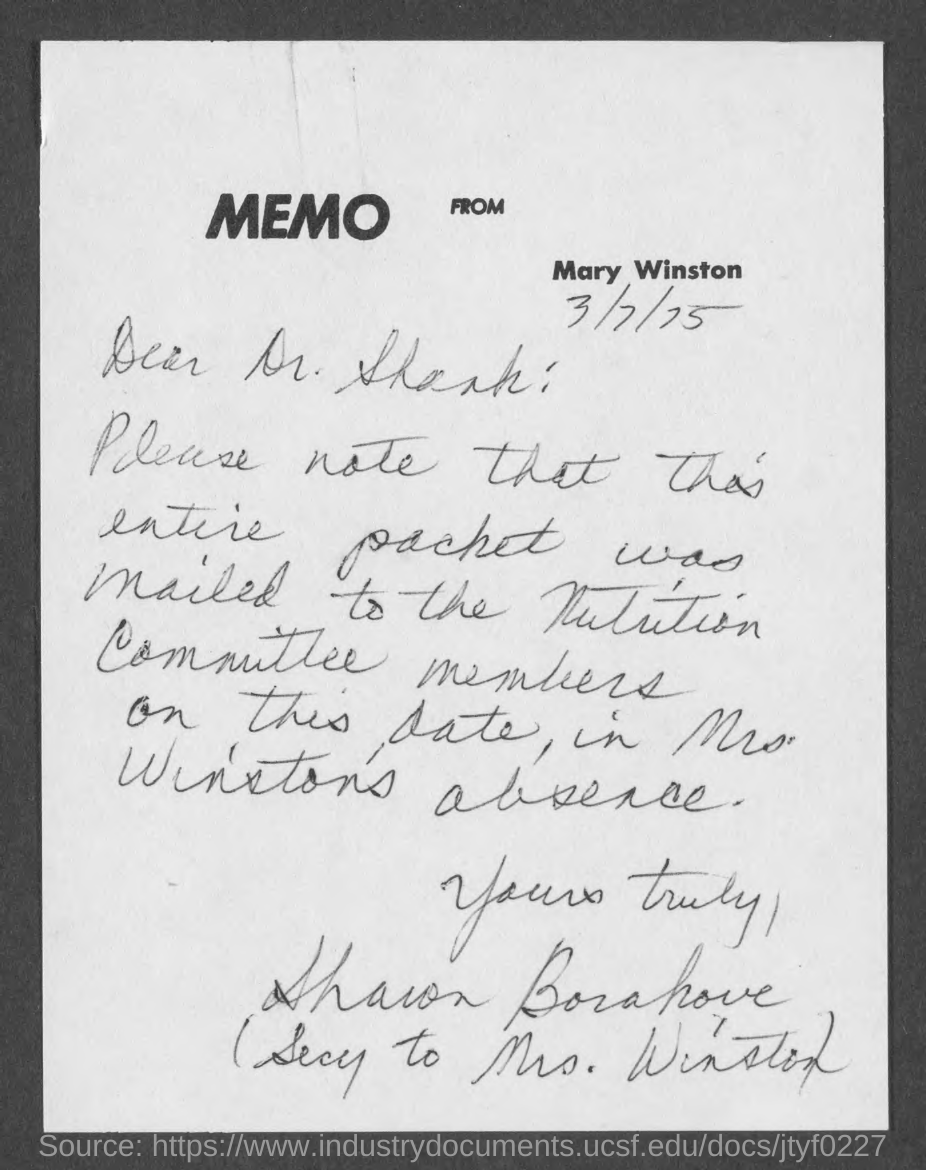Indicate a few pertinent items in this graphic. The memo is from Mary Winston. 